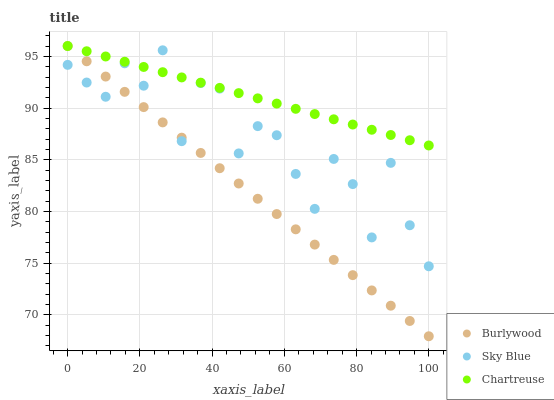Does Burlywood have the minimum area under the curve?
Answer yes or no. Yes. Does Chartreuse have the maximum area under the curve?
Answer yes or no. Yes. Does Sky Blue have the minimum area under the curve?
Answer yes or no. No. Does Sky Blue have the maximum area under the curve?
Answer yes or no. No. Is Chartreuse the smoothest?
Answer yes or no. Yes. Is Sky Blue the roughest?
Answer yes or no. Yes. Is Sky Blue the smoothest?
Answer yes or no. No. Is Chartreuse the roughest?
Answer yes or no. No. Does Burlywood have the lowest value?
Answer yes or no. Yes. Does Sky Blue have the lowest value?
Answer yes or no. No. Does Chartreuse have the highest value?
Answer yes or no. Yes. Does Sky Blue have the highest value?
Answer yes or no. No. Does Chartreuse intersect Sky Blue?
Answer yes or no. Yes. Is Chartreuse less than Sky Blue?
Answer yes or no. No. Is Chartreuse greater than Sky Blue?
Answer yes or no. No. 